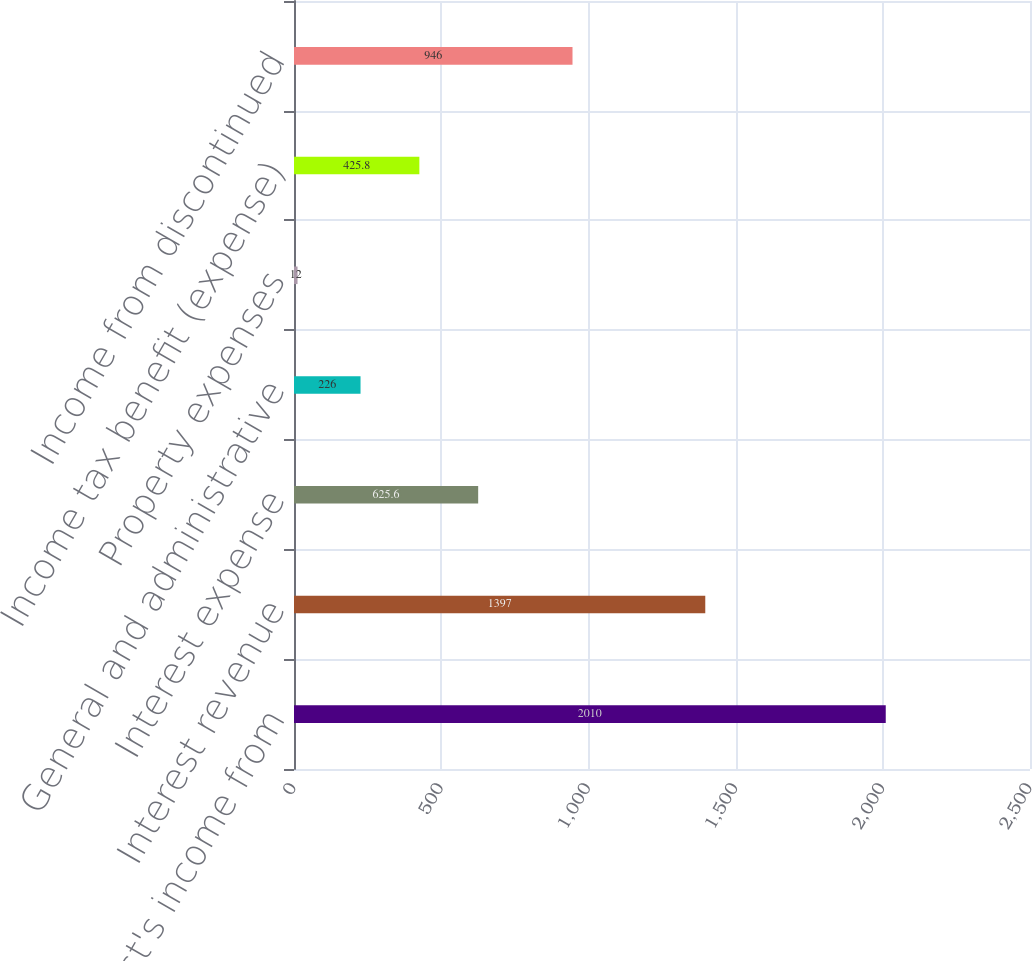Convert chart to OTSL. <chart><loc_0><loc_0><loc_500><loc_500><bar_chart><fcel>Crest's income from<fcel>Interest revenue<fcel>Interest expense<fcel>General and administrative<fcel>Property expenses<fcel>Income tax benefit (expense)<fcel>Income from discontinued<nl><fcel>2010<fcel>1397<fcel>625.6<fcel>226<fcel>12<fcel>425.8<fcel>946<nl></chart> 